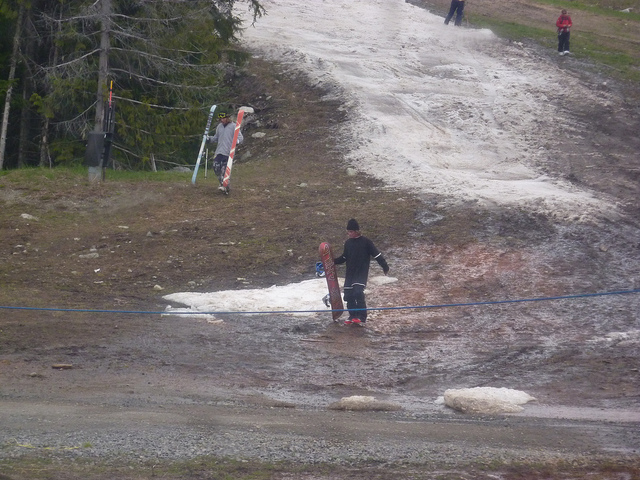<image>What is the person on the water wearing? I don't know what the person on the water is wearing. However, they might be wearing a sweater, snowsuit, or wetsuit. What is the person on the water wearing? I don't know what the person on the water is wearing. It can be clothes, sweater, snowsuit or wetsuit. 